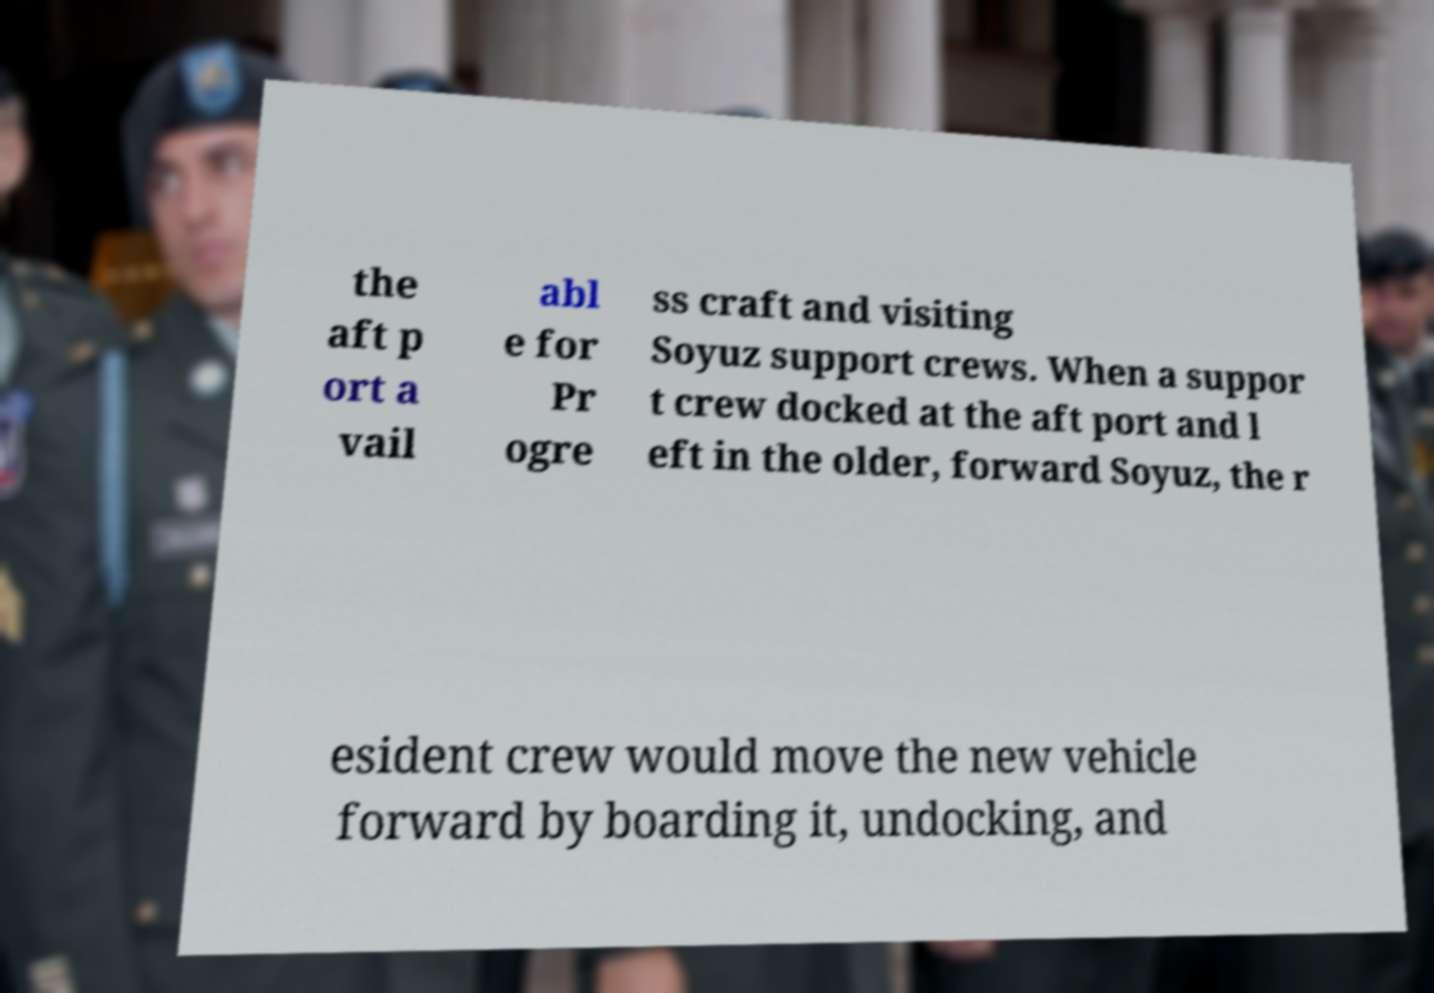Can you read and provide the text displayed in the image?This photo seems to have some interesting text. Can you extract and type it out for me? the aft p ort a vail abl e for Pr ogre ss craft and visiting Soyuz support crews. When a suppor t crew docked at the aft port and l eft in the older, forward Soyuz, the r esident crew would move the new vehicle forward by boarding it, undocking, and 